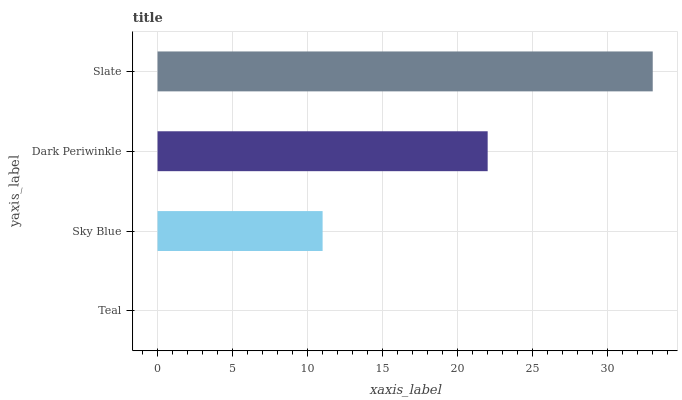Is Teal the minimum?
Answer yes or no. Yes. Is Slate the maximum?
Answer yes or no. Yes. Is Sky Blue the minimum?
Answer yes or no. No. Is Sky Blue the maximum?
Answer yes or no. No. Is Sky Blue greater than Teal?
Answer yes or no. Yes. Is Teal less than Sky Blue?
Answer yes or no. Yes. Is Teal greater than Sky Blue?
Answer yes or no. No. Is Sky Blue less than Teal?
Answer yes or no. No. Is Dark Periwinkle the high median?
Answer yes or no. Yes. Is Sky Blue the low median?
Answer yes or no. Yes. Is Slate the high median?
Answer yes or no. No. Is Dark Periwinkle the low median?
Answer yes or no. No. 